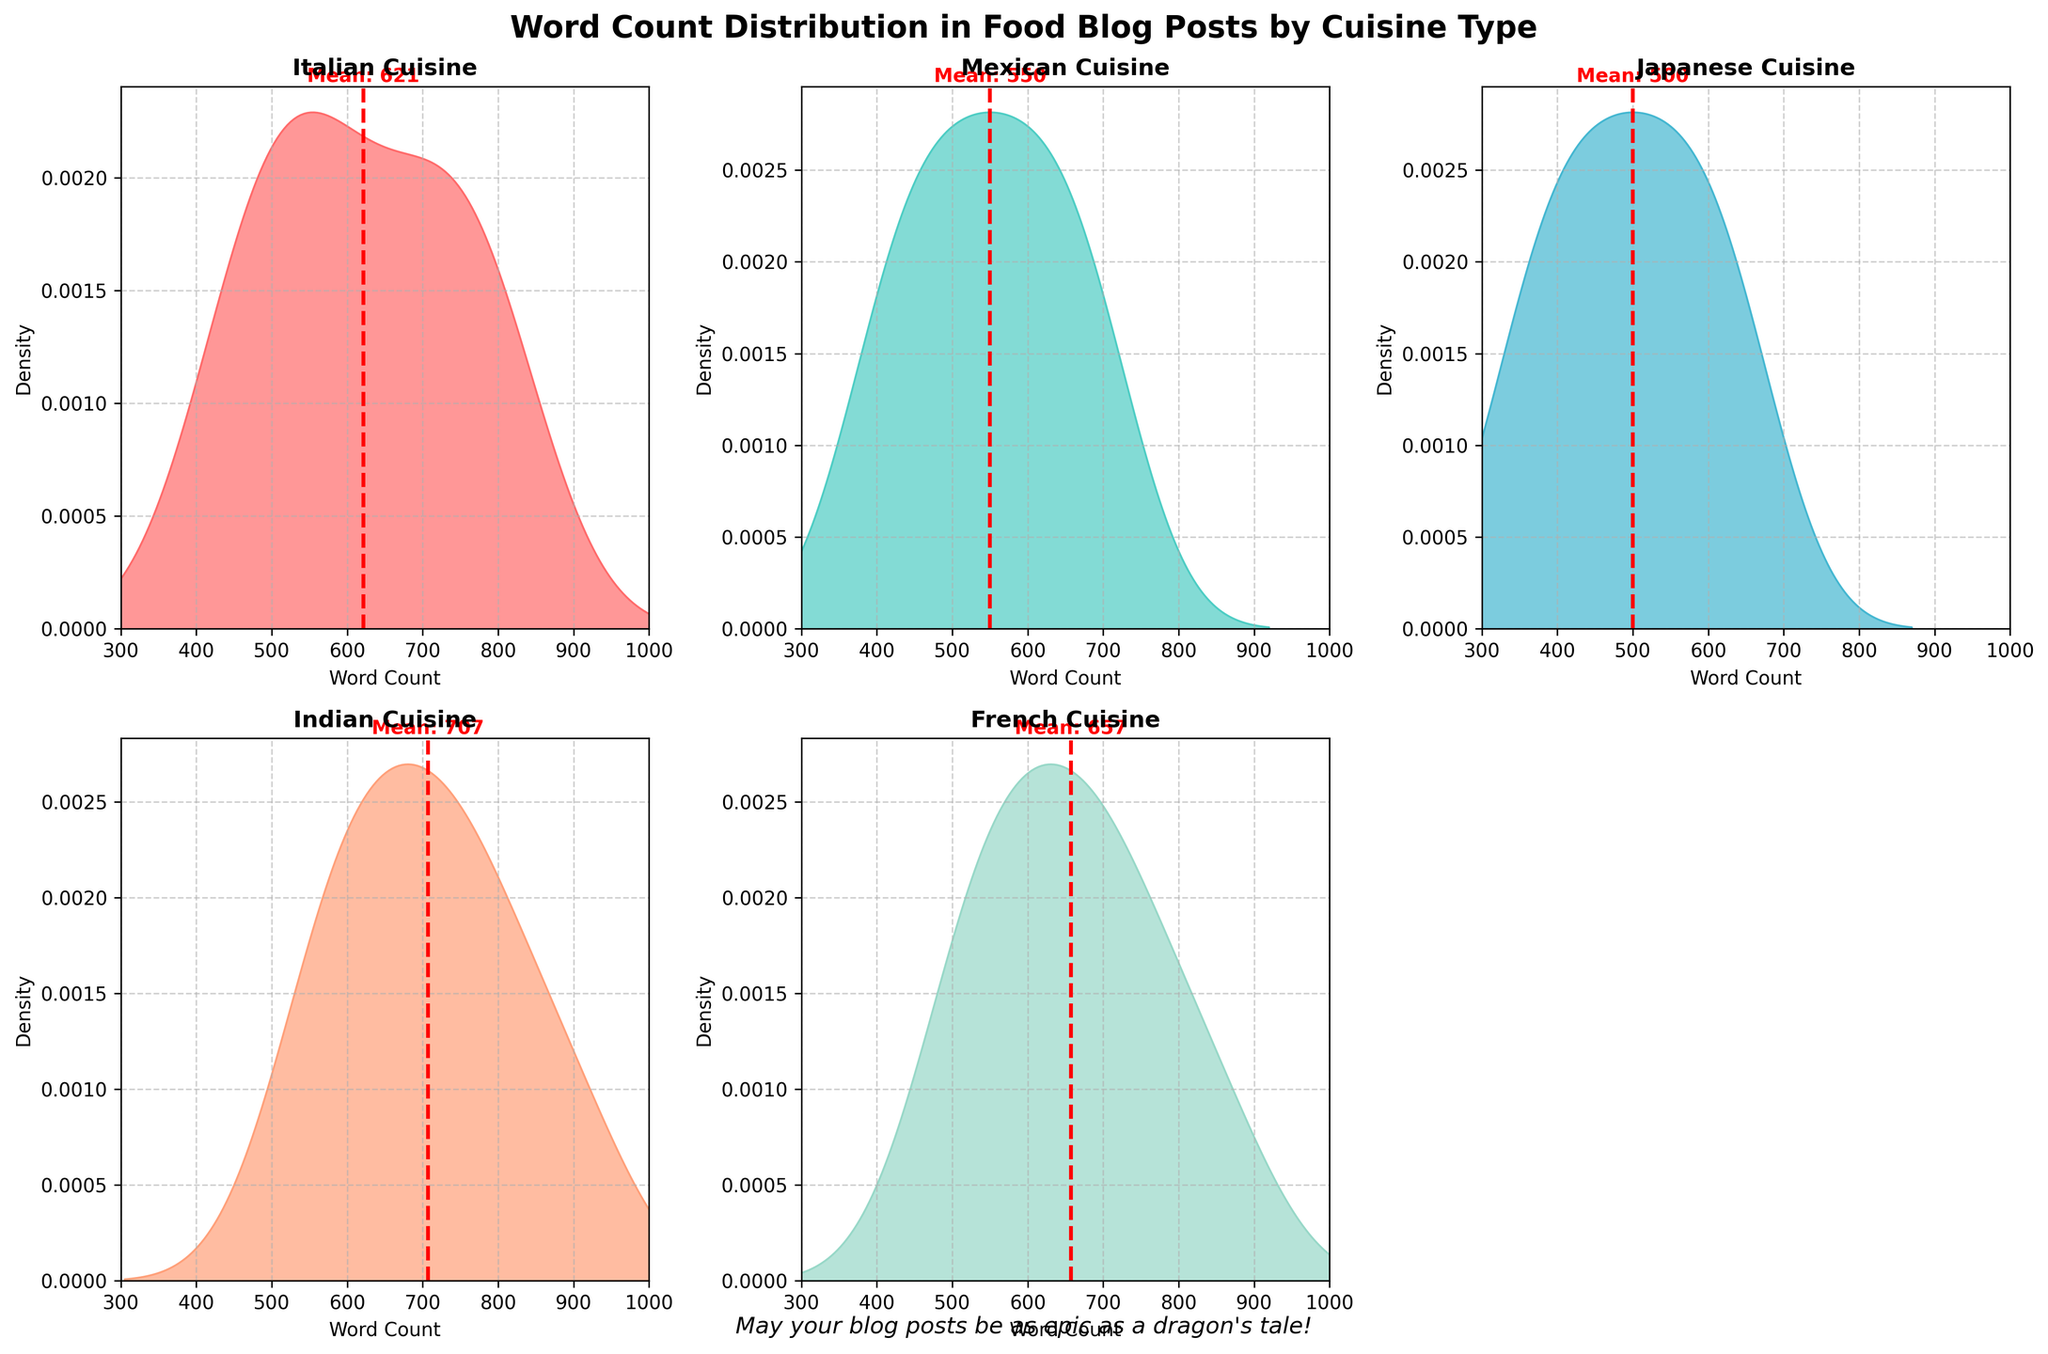What is the mean word count for Japanese cuisine blog posts? The mean word count is indicated by the red dashed line in the Japanese Cuisine subplot. The text annotation next to the line shows the value.
Answer: 500 What is the title of the figure? The title is located at the top center of the figure, written in a large and bold font.
Answer: Word Count Distribution in Food Blog Posts by Cuisine Type Which cuisine type has the highest mean word count? By comparing the red dashed lines in each subplot, the Indian Cuisine subplot shows the highest value for the mean word count.
Answer: Indian How many subplots are there in the figure? The figure is organized in a 2x3 grid layout, but one of the subplots is removed, leading to a total count of the remaining subplots.
Answer: 5 Which cuisine has the densest peak for word count distribution? The densest peak can be identified by looking at the height of the peaks in each subplot's density plot. The Middle Eastern Cuisine subplot has the highest peak.
Answer: Middle Eastern In which range does the word count distribution for Middle Eastern cuisine predominantly lie? The highest density area for Middle Eastern cuisine lies between the x-axis values where the peak is located, which is approximately between 400-700 words.
Answer: 400-700 Comparing Italian and French cuisines, which one has a wider spread in word count distribution? By observing the width of the density plots in both subplots, the French Cuisine density plot shows a wider spread compared to the Italian Cuisine plot.
Answer: French For Mexican cuisine, is the mean word count greater or less than 600 words? The red dashed line indicating the mean word count for Mexican Cuisine is slightly below the 600-word mark.
Answer: Less than 600 Do any of the subplots share the same x-axis range for word count? All subplots use a consistent x-axis range from 300 to 1000 words, as specified by the labeled ticks on each subplot.
Answer: Yes Is there any text at the bottom of the figure? If so, what does it say? The text at the bottom of the figure can be found below the subplots and reads: "May your blog posts be as epic as a dragon's tale!"
Answer: May your blog posts be as epic as a dragon's tale! 